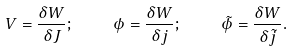Convert formula to latex. <formula><loc_0><loc_0><loc_500><loc_500>V = \frac { \delta W } { \delta J } ; \quad \phi = \frac { \delta W } { \delta j } ; \quad \tilde { \phi } = \frac { \delta W } { \delta \tilde { j } } .</formula> 